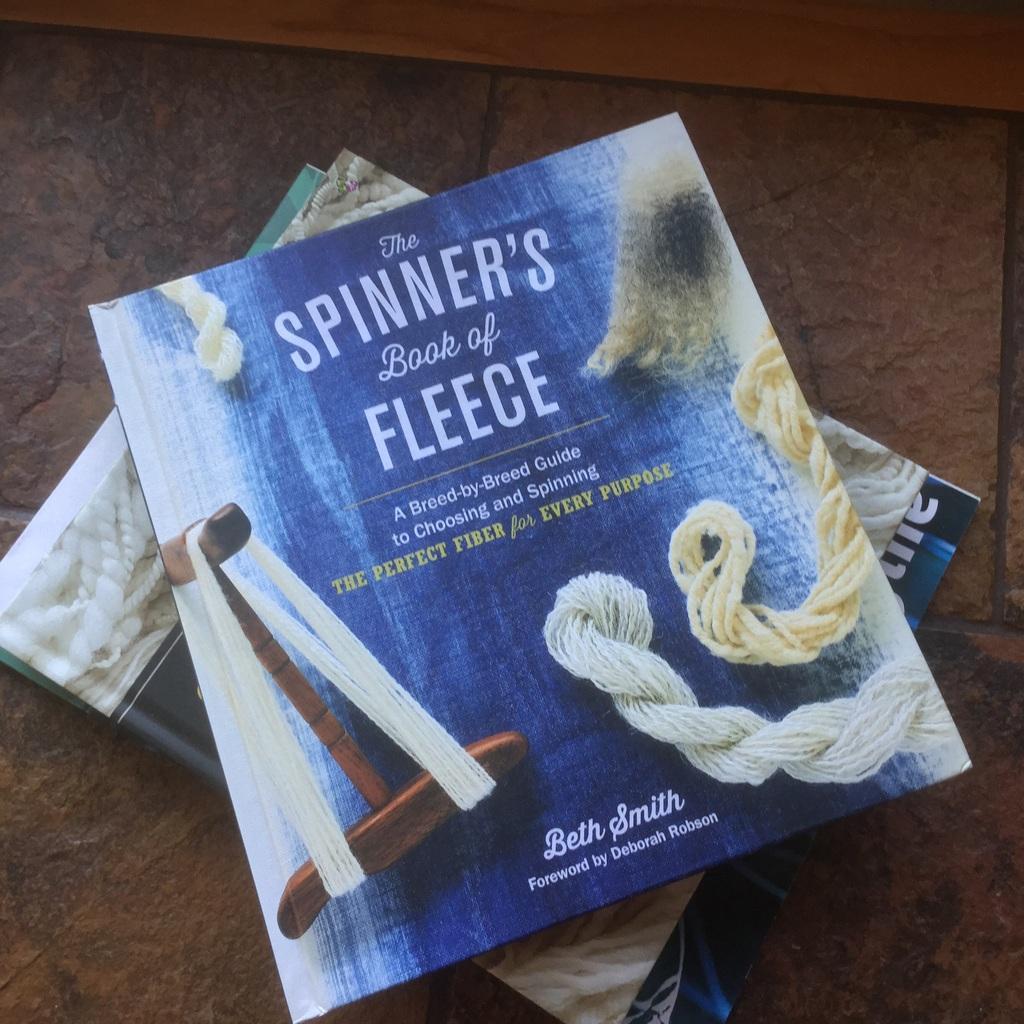Could you give a brief overview of what you see in this image? We can see books on the surface. 